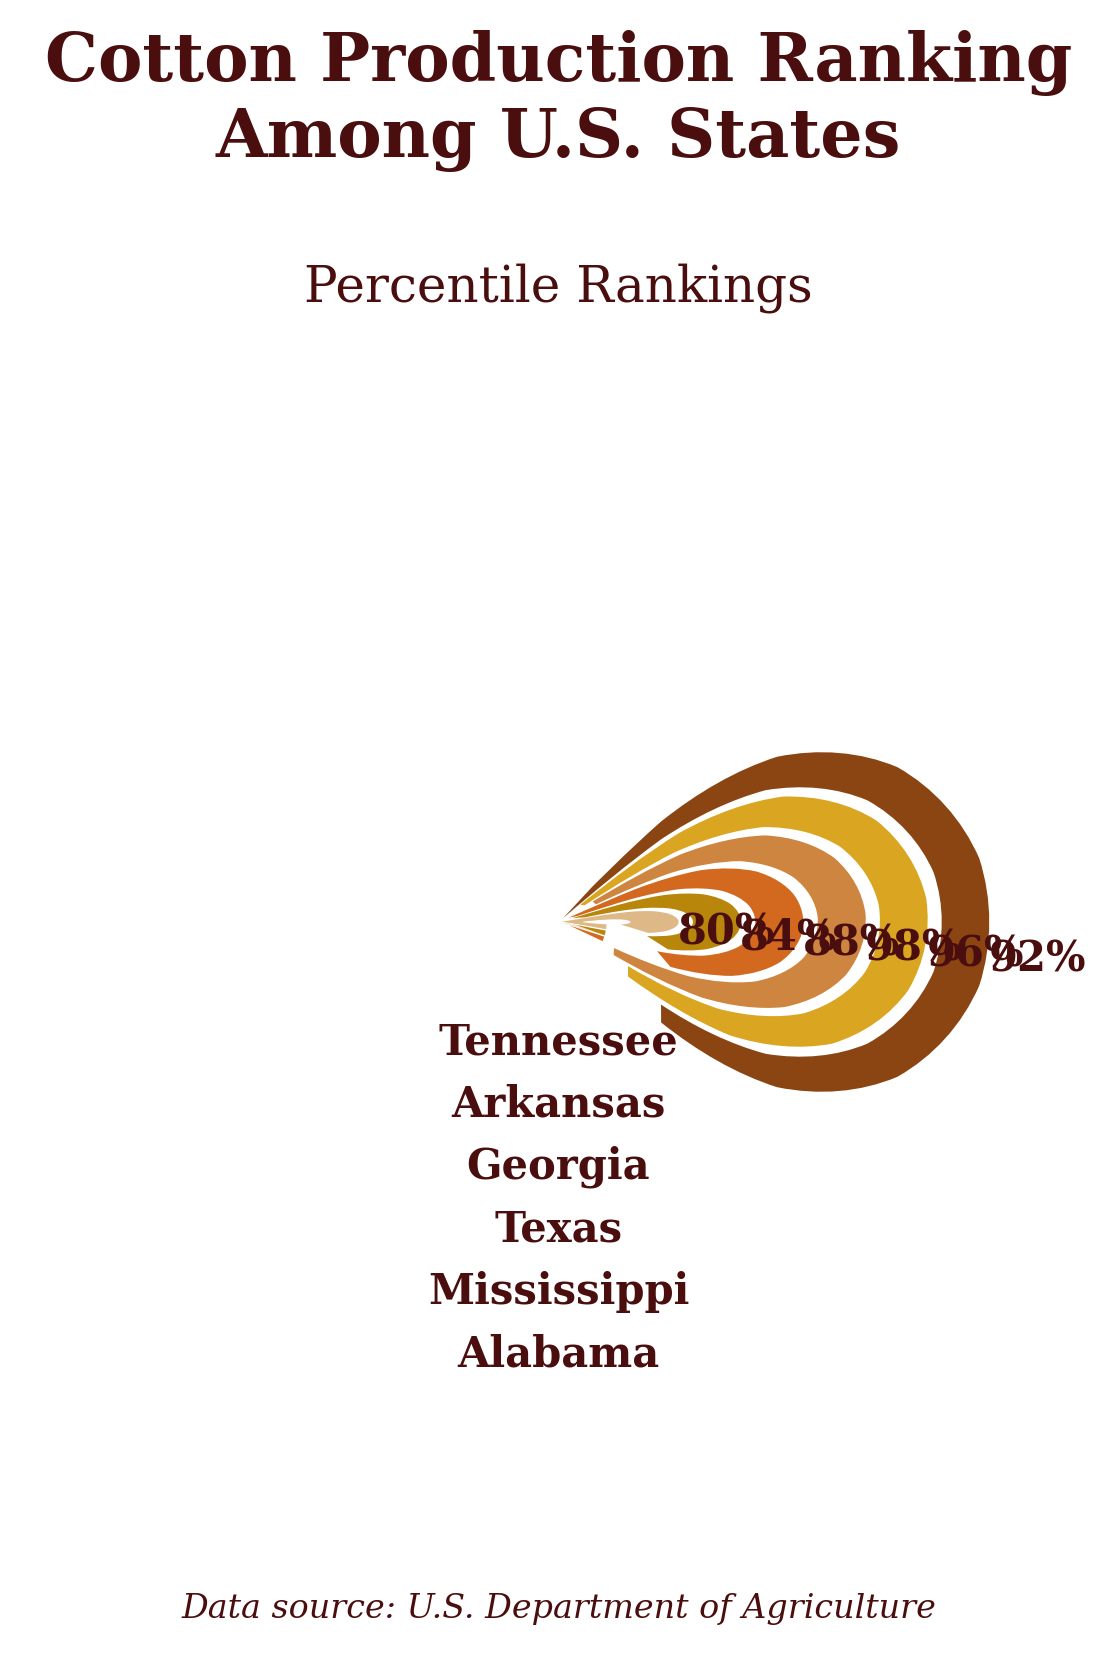what is the title of the chart? The title of the chart is "Cotton Production Ranking Among U.S. States" which is clearly shown at the top of the figure in bold letters.
Answer: Cotton Production Ranking Among U.S. States Which state has the highest percentile ranking in cotton production? By observing the lengths of the gauges, Texas has the highest percentile ranking shown as 98%.
Answer: Texas Which state has the lowest percentile ranking? By comparing the lengths of the gauges, Tennessee has the lowest percentile ranking shown as 80%.
Answer: Tennessee How does Alabama's ranking compare to Georgia's? Alabama has a percentile ranking of 92%, while Georgia has a percentile of 88%. Therefore, Alabama's ranking is higher than Georgia's.
Answer: Alabama's ranking is higher What is the average percentile ranking of the shown states? To find the average, sum the percentiles of all six states and divide by the number of states: (92 + 96 + 98 + 88 + 84 + 80) / 6 = 538 / 6 = 89.67.
Answer: 89.67 What color represents Alabama’s ranking? The color for Alabama's gauge section is brown (#CD853F).
Answer: Brown What is the difference in percentile between Alabama and Tennessee? The percentile for Alabama is 92%, and for Tennessee it is 80%. The difference is 92 - 80 = 12%.
Answer: 12% Does Mississippi have a higher percentile rank than Arkansas? By comparing the percentile values, Mississippi's percentile rank is 96%, while Arkansas is 84%. So, Mississippi has a higher percentile.
Answer: Yes Which state has a percentile closest to Alabama? The state closest in percentile to Alabama (92%) is Mississippi with a percentile of 96% (96 - 92 = 4%).
Answer: Mississippi 